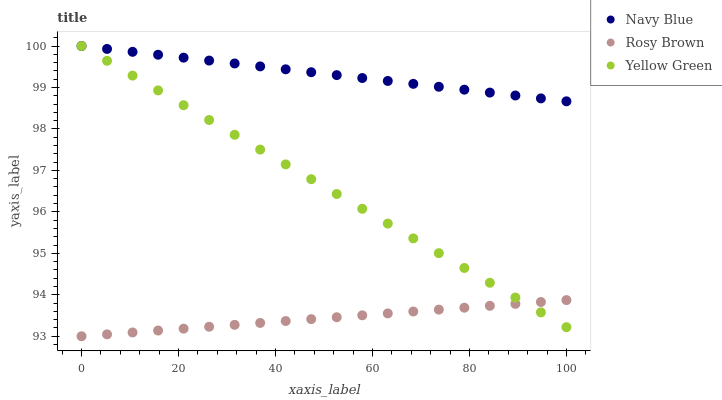Does Rosy Brown have the minimum area under the curve?
Answer yes or no. Yes. Does Navy Blue have the maximum area under the curve?
Answer yes or no. Yes. Does Yellow Green have the minimum area under the curve?
Answer yes or no. No. Does Yellow Green have the maximum area under the curve?
Answer yes or no. No. Is Navy Blue the smoothest?
Answer yes or no. Yes. Is Rosy Brown the roughest?
Answer yes or no. Yes. Is Yellow Green the smoothest?
Answer yes or no. No. Is Yellow Green the roughest?
Answer yes or no. No. Does Rosy Brown have the lowest value?
Answer yes or no. Yes. Does Yellow Green have the lowest value?
Answer yes or no. No. Does Yellow Green have the highest value?
Answer yes or no. Yes. Does Rosy Brown have the highest value?
Answer yes or no. No. Is Rosy Brown less than Navy Blue?
Answer yes or no. Yes. Is Navy Blue greater than Rosy Brown?
Answer yes or no. Yes. Does Yellow Green intersect Rosy Brown?
Answer yes or no. Yes. Is Yellow Green less than Rosy Brown?
Answer yes or no. No. Is Yellow Green greater than Rosy Brown?
Answer yes or no. No. Does Rosy Brown intersect Navy Blue?
Answer yes or no. No. 